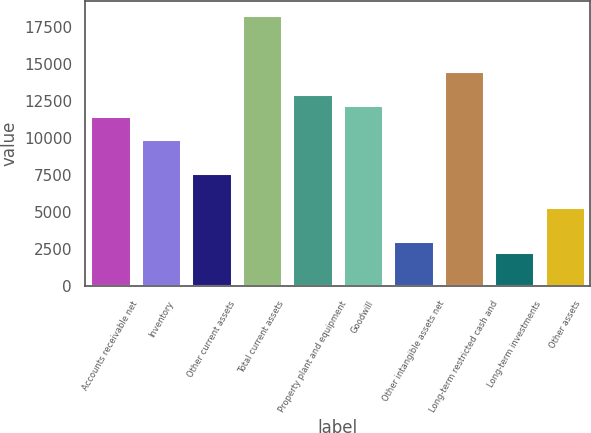Convert chart. <chart><loc_0><loc_0><loc_500><loc_500><bar_chart><fcel>Accounts receivable net<fcel>Inventory<fcel>Other current assets<fcel>Total current assets<fcel>Property plant and equipment<fcel>Goodwill<fcel>Other intangible assets net<fcel>Long-term restricted cash and<fcel>Long-term investments<fcel>Other assets<nl><fcel>11440<fcel>9914.8<fcel>7627<fcel>18303.4<fcel>12965.2<fcel>12202.6<fcel>3051.4<fcel>14490.4<fcel>2288.8<fcel>5339.2<nl></chart> 